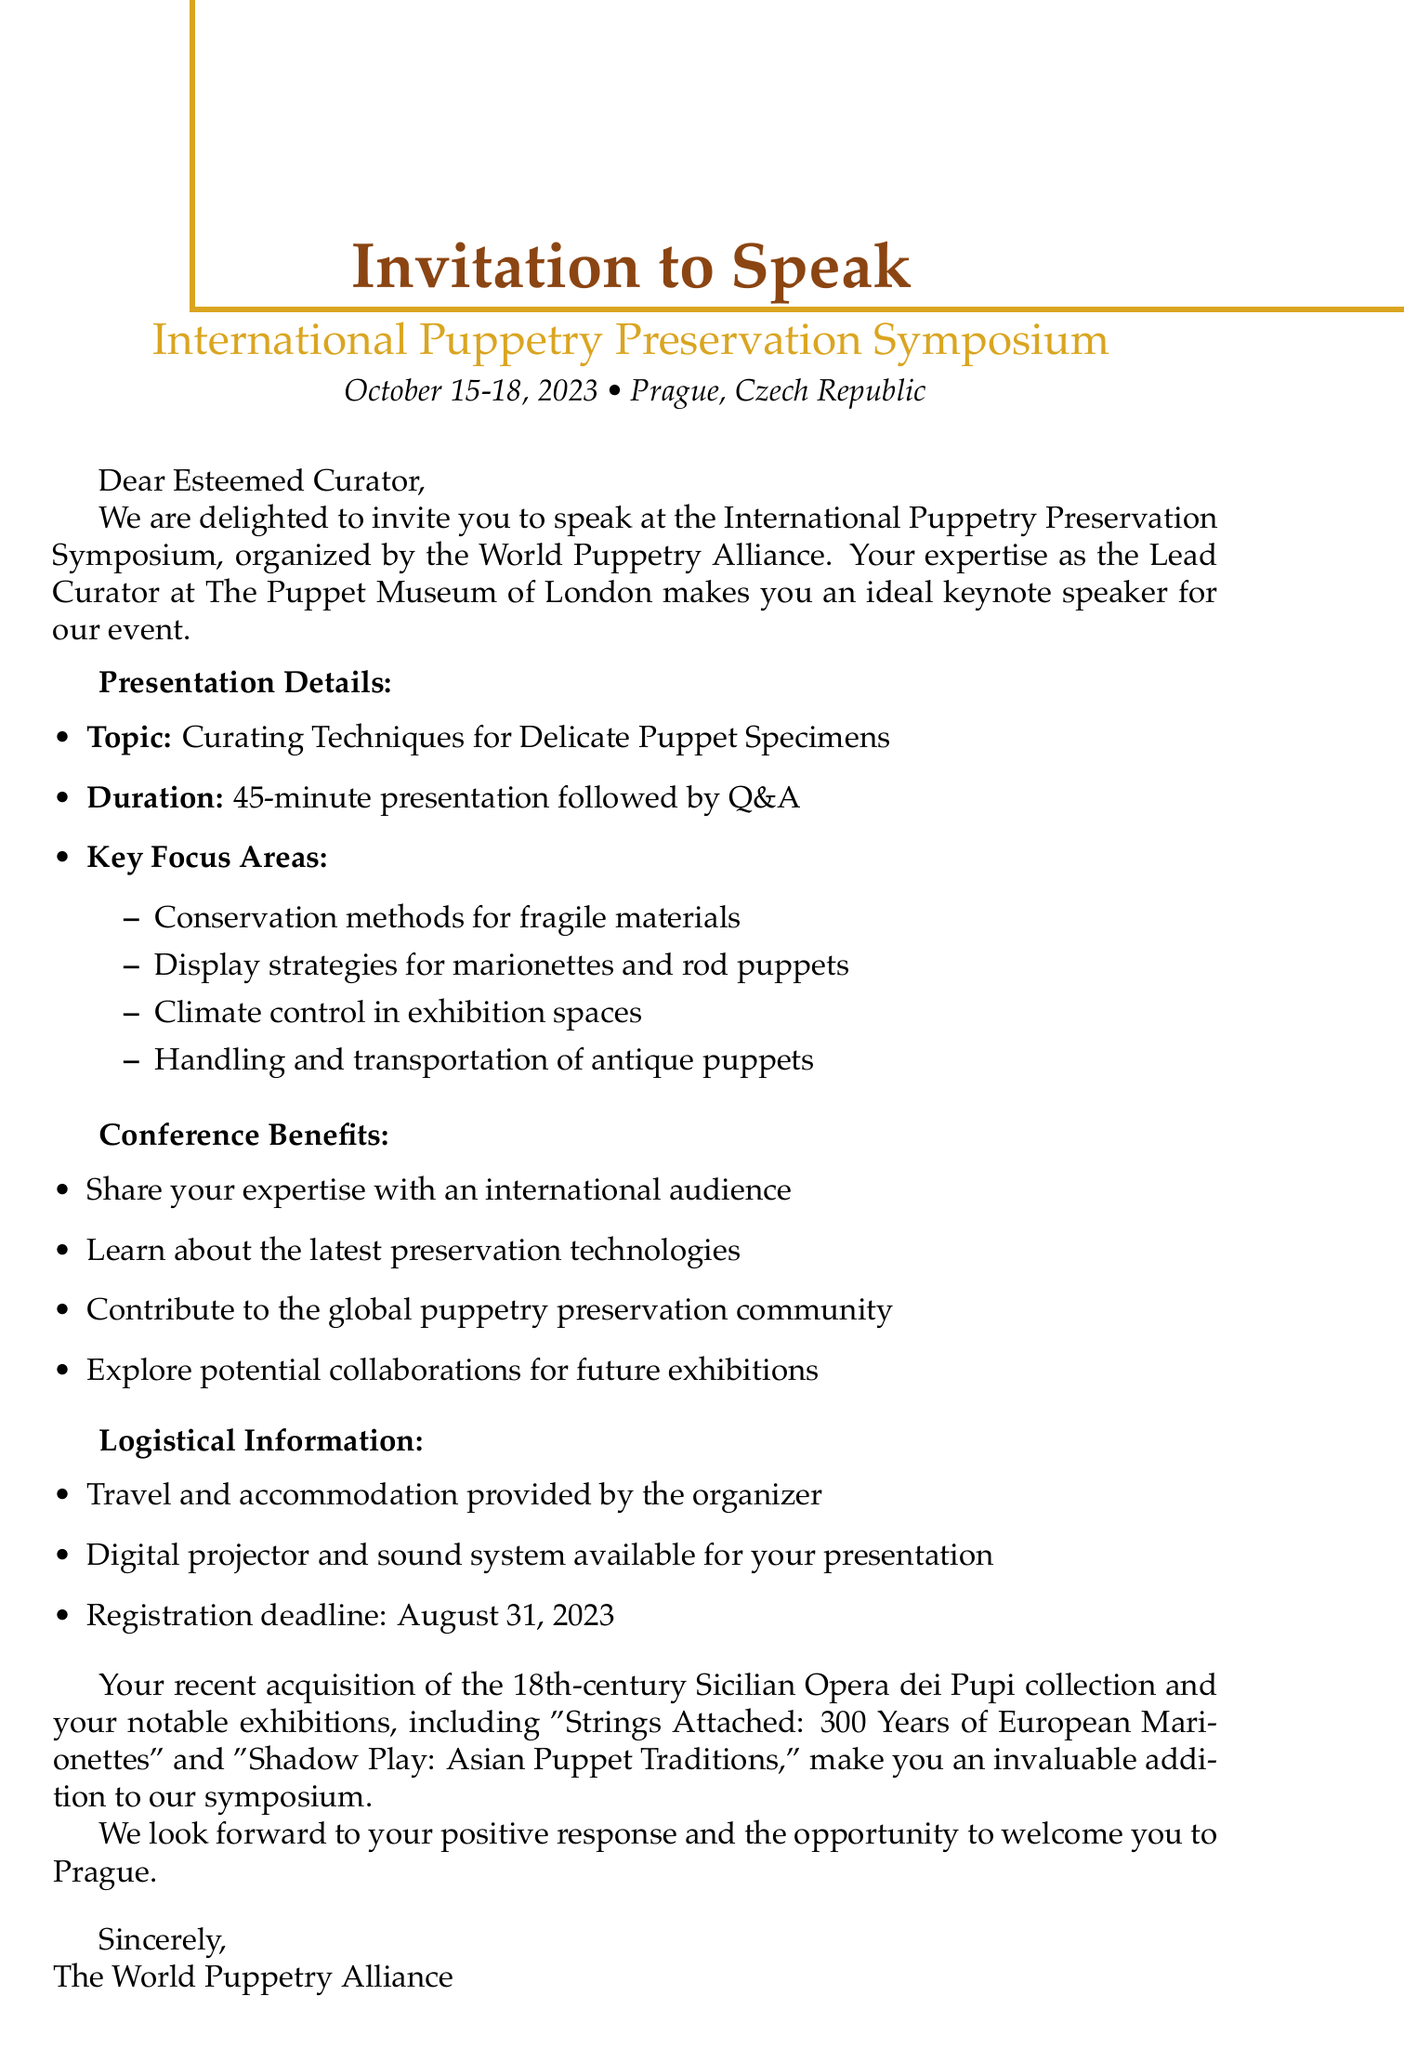What is the name of the conference? The name of the conference is highlighted in the document as "International Puppetry Preservation Symposium."
Answer: International Puppetry Preservation Symposium What are the dates of the conference? The document specifies the dates of the conference as October 15-18, 2023.
Answer: October 15-18, 2023 Who is the organizer of the event? The document states that the organizer of the event is the "World Puppetry Alliance."
Answer: World Puppetry Alliance What is the main topic of the presentation? The main topic of the presentation is explicitly given in the document as "Curating Techniques for Delicate Puppet Specimens."
Answer: Curating Techniques for Delicate Puppet Specimens What is one of the subtopics mentioned for the presentation? The document lists several subtopics; one example is "Conservation methods for fragile materials."
Answer: Conservation methods for fragile materials What is the duration of the presentation slot? The document indicates that the presentation duration is "45-minute presentation followed by Q&A."
Answer: 45-minute presentation What benefits are mentioned for attending the conference? The document lists several benefits, including "Share your expertise with an international audience."
Answer: Share your expertise with an international audience What is provided by the organizer for accommodation? The document mentions that "Travel and accommodation provided by the organizer."
Answer: Travel and accommodation What is the registration deadline? The registration deadline is clearly stated in the document as "August 31, 2023."
Answer: August 31, 2023 